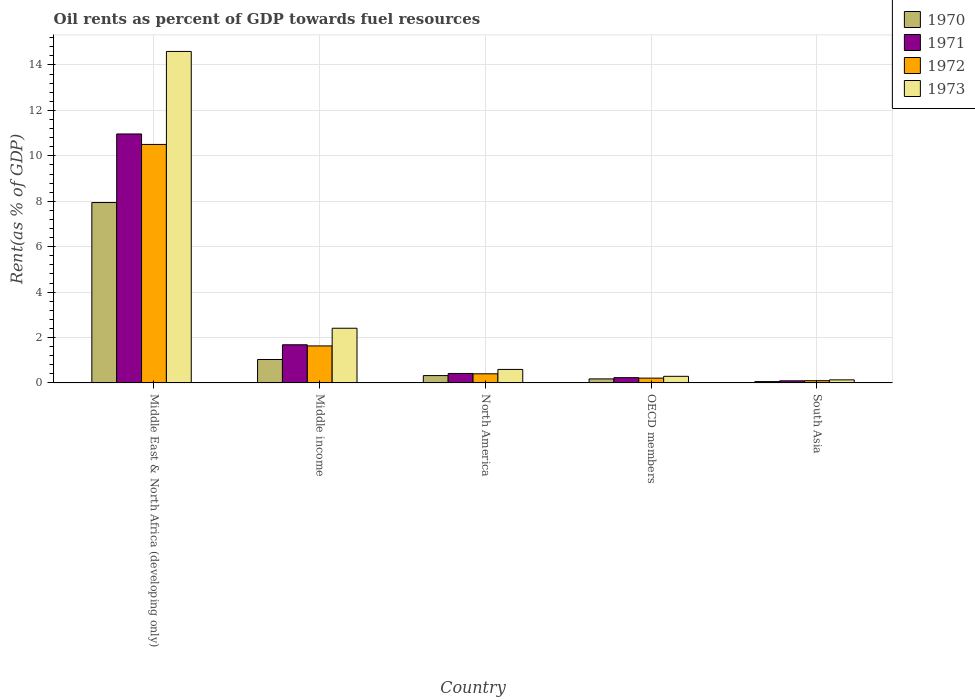Are the number of bars per tick equal to the number of legend labels?
Ensure brevity in your answer.  Yes. How many bars are there on the 5th tick from the right?
Your answer should be very brief. 4. What is the oil rent in 1972 in North America?
Offer a terse response. 0.4. Across all countries, what is the maximum oil rent in 1971?
Ensure brevity in your answer.  10.96. Across all countries, what is the minimum oil rent in 1971?
Provide a short and direct response. 0.09. In which country was the oil rent in 1971 maximum?
Provide a short and direct response. Middle East & North Africa (developing only). In which country was the oil rent in 1971 minimum?
Your response must be concise. South Asia. What is the total oil rent in 1970 in the graph?
Provide a succinct answer. 9.54. What is the difference between the oil rent in 1970 in Middle income and that in South Asia?
Give a very brief answer. 0.97. What is the difference between the oil rent in 1971 in North America and the oil rent in 1972 in OECD members?
Offer a terse response. 0.21. What is the average oil rent in 1972 per country?
Keep it short and to the point. 2.57. What is the difference between the oil rent of/in 1972 and oil rent of/in 1973 in Middle income?
Make the answer very short. -0.78. In how many countries, is the oil rent in 1972 greater than 9.6 %?
Ensure brevity in your answer.  1. What is the ratio of the oil rent in 1970 in Middle income to that in South Asia?
Your answer should be very brief. 17.23. Is the oil rent in 1972 in Middle income less than that in North America?
Offer a very short reply. No. Is the difference between the oil rent in 1972 in Middle income and South Asia greater than the difference between the oil rent in 1973 in Middle income and South Asia?
Give a very brief answer. No. What is the difference between the highest and the second highest oil rent in 1973?
Give a very brief answer. -1.81. What is the difference between the highest and the lowest oil rent in 1970?
Your response must be concise. 7.88. In how many countries, is the oil rent in 1971 greater than the average oil rent in 1971 taken over all countries?
Your answer should be very brief. 1. Is the sum of the oil rent in 1972 in Middle income and OECD members greater than the maximum oil rent in 1971 across all countries?
Make the answer very short. No. What does the 1st bar from the left in South Asia represents?
Ensure brevity in your answer.  1970. What does the 3rd bar from the right in Middle income represents?
Offer a terse response. 1971. How many bars are there?
Your response must be concise. 20. How many countries are there in the graph?
Your answer should be very brief. 5. Does the graph contain any zero values?
Offer a very short reply. No. How many legend labels are there?
Give a very brief answer. 4. What is the title of the graph?
Keep it short and to the point. Oil rents as percent of GDP towards fuel resources. What is the label or title of the Y-axis?
Your answer should be compact. Rent(as % of GDP). What is the Rent(as % of GDP) in 1970 in Middle East & North Africa (developing only)?
Your response must be concise. 7.94. What is the Rent(as % of GDP) in 1971 in Middle East & North Africa (developing only)?
Offer a very short reply. 10.96. What is the Rent(as % of GDP) of 1972 in Middle East & North Africa (developing only)?
Offer a terse response. 10.5. What is the Rent(as % of GDP) in 1973 in Middle East & North Africa (developing only)?
Your response must be concise. 14.6. What is the Rent(as % of GDP) of 1970 in Middle income?
Ensure brevity in your answer.  1.03. What is the Rent(as % of GDP) in 1971 in Middle income?
Provide a succinct answer. 1.68. What is the Rent(as % of GDP) of 1972 in Middle income?
Your answer should be very brief. 1.63. What is the Rent(as % of GDP) in 1973 in Middle income?
Your answer should be compact. 2.41. What is the Rent(as % of GDP) of 1970 in North America?
Keep it short and to the point. 0.32. What is the Rent(as % of GDP) in 1971 in North America?
Your answer should be compact. 0.42. What is the Rent(as % of GDP) in 1972 in North America?
Ensure brevity in your answer.  0.4. What is the Rent(as % of GDP) in 1973 in North America?
Offer a very short reply. 0.6. What is the Rent(as % of GDP) in 1970 in OECD members?
Provide a short and direct response. 0.18. What is the Rent(as % of GDP) of 1971 in OECD members?
Make the answer very short. 0.23. What is the Rent(as % of GDP) in 1972 in OECD members?
Give a very brief answer. 0.21. What is the Rent(as % of GDP) of 1973 in OECD members?
Your response must be concise. 0.29. What is the Rent(as % of GDP) of 1970 in South Asia?
Keep it short and to the point. 0.06. What is the Rent(as % of GDP) in 1971 in South Asia?
Your answer should be very brief. 0.09. What is the Rent(as % of GDP) in 1972 in South Asia?
Make the answer very short. 0.1. What is the Rent(as % of GDP) in 1973 in South Asia?
Ensure brevity in your answer.  0.14. Across all countries, what is the maximum Rent(as % of GDP) in 1970?
Your response must be concise. 7.94. Across all countries, what is the maximum Rent(as % of GDP) of 1971?
Your answer should be compact. 10.96. Across all countries, what is the maximum Rent(as % of GDP) in 1972?
Your response must be concise. 10.5. Across all countries, what is the maximum Rent(as % of GDP) of 1973?
Offer a terse response. 14.6. Across all countries, what is the minimum Rent(as % of GDP) of 1970?
Your answer should be compact. 0.06. Across all countries, what is the minimum Rent(as % of GDP) of 1971?
Make the answer very short. 0.09. Across all countries, what is the minimum Rent(as % of GDP) of 1972?
Your answer should be very brief. 0.1. Across all countries, what is the minimum Rent(as % of GDP) in 1973?
Offer a terse response. 0.14. What is the total Rent(as % of GDP) of 1970 in the graph?
Your answer should be very brief. 9.54. What is the total Rent(as % of GDP) in 1971 in the graph?
Provide a succinct answer. 13.39. What is the total Rent(as % of GDP) of 1972 in the graph?
Your answer should be compact. 12.85. What is the total Rent(as % of GDP) of 1973 in the graph?
Your answer should be compact. 18.03. What is the difference between the Rent(as % of GDP) in 1970 in Middle East & North Africa (developing only) and that in Middle income?
Your answer should be very brief. 6.91. What is the difference between the Rent(as % of GDP) of 1971 in Middle East & North Africa (developing only) and that in Middle income?
Keep it short and to the point. 9.28. What is the difference between the Rent(as % of GDP) in 1972 in Middle East & North Africa (developing only) and that in Middle income?
Make the answer very short. 8.87. What is the difference between the Rent(as % of GDP) of 1973 in Middle East & North Africa (developing only) and that in Middle income?
Your answer should be compact. 12.19. What is the difference between the Rent(as % of GDP) in 1970 in Middle East & North Africa (developing only) and that in North America?
Provide a succinct answer. 7.62. What is the difference between the Rent(as % of GDP) of 1971 in Middle East & North Africa (developing only) and that in North America?
Your answer should be very brief. 10.55. What is the difference between the Rent(as % of GDP) in 1972 in Middle East & North Africa (developing only) and that in North America?
Provide a succinct answer. 10.1. What is the difference between the Rent(as % of GDP) of 1973 in Middle East & North Africa (developing only) and that in North America?
Keep it short and to the point. 14. What is the difference between the Rent(as % of GDP) of 1970 in Middle East & North Africa (developing only) and that in OECD members?
Your answer should be compact. 7.77. What is the difference between the Rent(as % of GDP) of 1971 in Middle East & North Africa (developing only) and that in OECD members?
Provide a succinct answer. 10.73. What is the difference between the Rent(as % of GDP) in 1972 in Middle East & North Africa (developing only) and that in OECD members?
Offer a very short reply. 10.29. What is the difference between the Rent(as % of GDP) of 1973 in Middle East & North Africa (developing only) and that in OECD members?
Provide a succinct answer. 14.3. What is the difference between the Rent(as % of GDP) in 1970 in Middle East & North Africa (developing only) and that in South Asia?
Your answer should be compact. 7.88. What is the difference between the Rent(as % of GDP) in 1971 in Middle East & North Africa (developing only) and that in South Asia?
Give a very brief answer. 10.87. What is the difference between the Rent(as % of GDP) of 1972 in Middle East & North Africa (developing only) and that in South Asia?
Keep it short and to the point. 10.4. What is the difference between the Rent(as % of GDP) of 1973 in Middle East & North Africa (developing only) and that in South Asia?
Your answer should be very brief. 14.46. What is the difference between the Rent(as % of GDP) in 1970 in Middle income and that in North America?
Your answer should be very brief. 0.71. What is the difference between the Rent(as % of GDP) of 1971 in Middle income and that in North America?
Offer a terse response. 1.26. What is the difference between the Rent(as % of GDP) of 1972 in Middle income and that in North America?
Offer a terse response. 1.23. What is the difference between the Rent(as % of GDP) in 1973 in Middle income and that in North America?
Give a very brief answer. 1.81. What is the difference between the Rent(as % of GDP) of 1970 in Middle income and that in OECD members?
Offer a terse response. 0.85. What is the difference between the Rent(as % of GDP) of 1971 in Middle income and that in OECD members?
Provide a succinct answer. 1.45. What is the difference between the Rent(as % of GDP) in 1972 in Middle income and that in OECD members?
Give a very brief answer. 1.42. What is the difference between the Rent(as % of GDP) of 1973 in Middle income and that in OECD members?
Give a very brief answer. 2.12. What is the difference between the Rent(as % of GDP) of 1970 in Middle income and that in South Asia?
Your answer should be compact. 0.97. What is the difference between the Rent(as % of GDP) in 1971 in Middle income and that in South Asia?
Ensure brevity in your answer.  1.59. What is the difference between the Rent(as % of GDP) of 1972 in Middle income and that in South Asia?
Give a very brief answer. 1.53. What is the difference between the Rent(as % of GDP) of 1973 in Middle income and that in South Asia?
Provide a succinct answer. 2.27. What is the difference between the Rent(as % of GDP) in 1970 in North America and that in OECD members?
Keep it short and to the point. 0.15. What is the difference between the Rent(as % of GDP) of 1971 in North America and that in OECD members?
Offer a very short reply. 0.18. What is the difference between the Rent(as % of GDP) in 1972 in North America and that in OECD members?
Your answer should be compact. 0.19. What is the difference between the Rent(as % of GDP) in 1973 in North America and that in OECD members?
Provide a succinct answer. 0.3. What is the difference between the Rent(as % of GDP) in 1970 in North America and that in South Asia?
Keep it short and to the point. 0.26. What is the difference between the Rent(as % of GDP) in 1971 in North America and that in South Asia?
Ensure brevity in your answer.  0.32. What is the difference between the Rent(as % of GDP) of 1972 in North America and that in South Asia?
Provide a short and direct response. 0.3. What is the difference between the Rent(as % of GDP) in 1973 in North America and that in South Asia?
Your response must be concise. 0.46. What is the difference between the Rent(as % of GDP) in 1970 in OECD members and that in South Asia?
Provide a short and direct response. 0.12. What is the difference between the Rent(as % of GDP) of 1971 in OECD members and that in South Asia?
Provide a short and direct response. 0.14. What is the difference between the Rent(as % of GDP) of 1972 in OECD members and that in South Asia?
Offer a terse response. 0.11. What is the difference between the Rent(as % of GDP) of 1973 in OECD members and that in South Asia?
Provide a succinct answer. 0.16. What is the difference between the Rent(as % of GDP) in 1970 in Middle East & North Africa (developing only) and the Rent(as % of GDP) in 1971 in Middle income?
Offer a very short reply. 6.26. What is the difference between the Rent(as % of GDP) of 1970 in Middle East & North Africa (developing only) and the Rent(as % of GDP) of 1972 in Middle income?
Your answer should be compact. 6.31. What is the difference between the Rent(as % of GDP) in 1970 in Middle East & North Africa (developing only) and the Rent(as % of GDP) in 1973 in Middle income?
Offer a terse response. 5.53. What is the difference between the Rent(as % of GDP) in 1971 in Middle East & North Africa (developing only) and the Rent(as % of GDP) in 1972 in Middle income?
Your answer should be compact. 9.33. What is the difference between the Rent(as % of GDP) in 1971 in Middle East & North Africa (developing only) and the Rent(as % of GDP) in 1973 in Middle income?
Offer a very short reply. 8.55. What is the difference between the Rent(as % of GDP) of 1972 in Middle East & North Africa (developing only) and the Rent(as % of GDP) of 1973 in Middle income?
Ensure brevity in your answer.  8.09. What is the difference between the Rent(as % of GDP) in 1970 in Middle East & North Africa (developing only) and the Rent(as % of GDP) in 1971 in North America?
Offer a very short reply. 7.53. What is the difference between the Rent(as % of GDP) in 1970 in Middle East & North Africa (developing only) and the Rent(as % of GDP) in 1972 in North America?
Offer a terse response. 7.54. What is the difference between the Rent(as % of GDP) of 1970 in Middle East & North Africa (developing only) and the Rent(as % of GDP) of 1973 in North America?
Offer a very short reply. 7.35. What is the difference between the Rent(as % of GDP) of 1971 in Middle East & North Africa (developing only) and the Rent(as % of GDP) of 1972 in North America?
Offer a terse response. 10.56. What is the difference between the Rent(as % of GDP) in 1971 in Middle East & North Africa (developing only) and the Rent(as % of GDP) in 1973 in North America?
Offer a very short reply. 10.37. What is the difference between the Rent(as % of GDP) in 1972 in Middle East & North Africa (developing only) and the Rent(as % of GDP) in 1973 in North America?
Provide a short and direct response. 9.91. What is the difference between the Rent(as % of GDP) of 1970 in Middle East & North Africa (developing only) and the Rent(as % of GDP) of 1971 in OECD members?
Give a very brief answer. 7.71. What is the difference between the Rent(as % of GDP) of 1970 in Middle East & North Africa (developing only) and the Rent(as % of GDP) of 1972 in OECD members?
Make the answer very short. 7.73. What is the difference between the Rent(as % of GDP) of 1970 in Middle East & North Africa (developing only) and the Rent(as % of GDP) of 1973 in OECD members?
Make the answer very short. 7.65. What is the difference between the Rent(as % of GDP) of 1971 in Middle East & North Africa (developing only) and the Rent(as % of GDP) of 1972 in OECD members?
Make the answer very short. 10.75. What is the difference between the Rent(as % of GDP) of 1971 in Middle East & North Africa (developing only) and the Rent(as % of GDP) of 1973 in OECD members?
Your answer should be compact. 10.67. What is the difference between the Rent(as % of GDP) in 1972 in Middle East & North Africa (developing only) and the Rent(as % of GDP) in 1973 in OECD members?
Provide a succinct answer. 10.21. What is the difference between the Rent(as % of GDP) of 1970 in Middle East & North Africa (developing only) and the Rent(as % of GDP) of 1971 in South Asia?
Ensure brevity in your answer.  7.85. What is the difference between the Rent(as % of GDP) of 1970 in Middle East & North Africa (developing only) and the Rent(as % of GDP) of 1972 in South Asia?
Your answer should be very brief. 7.84. What is the difference between the Rent(as % of GDP) in 1970 in Middle East & North Africa (developing only) and the Rent(as % of GDP) in 1973 in South Asia?
Offer a very short reply. 7.81. What is the difference between the Rent(as % of GDP) in 1971 in Middle East & North Africa (developing only) and the Rent(as % of GDP) in 1972 in South Asia?
Ensure brevity in your answer.  10.86. What is the difference between the Rent(as % of GDP) of 1971 in Middle East & North Africa (developing only) and the Rent(as % of GDP) of 1973 in South Asia?
Provide a short and direct response. 10.83. What is the difference between the Rent(as % of GDP) in 1972 in Middle East & North Africa (developing only) and the Rent(as % of GDP) in 1973 in South Asia?
Offer a very short reply. 10.37. What is the difference between the Rent(as % of GDP) of 1970 in Middle income and the Rent(as % of GDP) of 1971 in North America?
Offer a very short reply. 0.61. What is the difference between the Rent(as % of GDP) of 1970 in Middle income and the Rent(as % of GDP) of 1972 in North America?
Provide a short and direct response. 0.63. What is the difference between the Rent(as % of GDP) in 1970 in Middle income and the Rent(as % of GDP) in 1973 in North America?
Provide a succinct answer. 0.44. What is the difference between the Rent(as % of GDP) of 1971 in Middle income and the Rent(as % of GDP) of 1972 in North America?
Your answer should be very brief. 1.28. What is the difference between the Rent(as % of GDP) in 1971 in Middle income and the Rent(as % of GDP) in 1973 in North America?
Offer a terse response. 1.09. What is the difference between the Rent(as % of GDP) in 1972 in Middle income and the Rent(as % of GDP) in 1973 in North America?
Your answer should be very brief. 1.04. What is the difference between the Rent(as % of GDP) of 1970 in Middle income and the Rent(as % of GDP) of 1971 in OECD members?
Your answer should be compact. 0.8. What is the difference between the Rent(as % of GDP) of 1970 in Middle income and the Rent(as % of GDP) of 1972 in OECD members?
Your answer should be compact. 0.82. What is the difference between the Rent(as % of GDP) in 1970 in Middle income and the Rent(as % of GDP) in 1973 in OECD members?
Ensure brevity in your answer.  0.74. What is the difference between the Rent(as % of GDP) in 1971 in Middle income and the Rent(as % of GDP) in 1972 in OECD members?
Make the answer very short. 1.47. What is the difference between the Rent(as % of GDP) in 1971 in Middle income and the Rent(as % of GDP) in 1973 in OECD members?
Give a very brief answer. 1.39. What is the difference between the Rent(as % of GDP) in 1972 in Middle income and the Rent(as % of GDP) in 1973 in OECD members?
Offer a very short reply. 1.34. What is the difference between the Rent(as % of GDP) of 1970 in Middle income and the Rent(as % of GDP) of 1971 in South Asia?
Provide a short and direct response. 0.94. What is the difference between the Rent(as % of GDP) of 1970 in Middle income and the Rent(as % of GDP) of 1972 in South Asia?
Provide a short and direct response. 0.93. What is the difference between the Rent(as % of GDP) of 1970 in Middle income and the Rent(as % of GDP) of 1973 in South Asia?
Make the answer very short. 0.9. What is the difference between the Rent(as % of GDP) of 1971 in Middle income and the Rent(as % of GDP) of 1972 in South Asia?
Offer a very short reply. 1.58. What is the difference between the Rent(as % of GDP) of 1971 in Middle income and the Rent(as % of GDP) of 1973 in South Asia?
Your answer should be compact. 1.55. What is the difference between the Rent(as % of GDP) in 1972 in Middle income and the Rent(as % of GDP) in 1973 in South Asia?
Provide a succinct answer. 1.5. What is the difference between the Rent(as % of GDP) in 1970 in North America and the Rent(as % of GDP) in 1971 in OECD members?
Offer a terse response. 0.09. What is the difference between the Rent(as % of GDP) of 1970 in North America and the Rent(as % of GDP) of 1972 in OECD members?
Offer a very short reply. 0.11. What is the difference between the Rent(as % of GDP) of 1970 in North America and the Rent(as % of GDP) of 1973 in OECD members?
Your response must be concise. 0.03. What is the difference between the Rent(as % of GDP) of 1971 in North America and the Rent(as % of GDP) of 1972 in OECD members?
Provide a short and direct response. 0.21. What is the difference between the Rent(as % of GDP) of 1971 in North America and the Rent(as % of GDP) of 1973 in OECD members?
Offer a very short reply. 0.13. What is the difference between the Rent(as % of GDP) of 1972 in North America and the Rent(as % of GDP) of 1973 in OECD members?
Ensure brevity in your answer.  0.11. What is the difference between the Rent(as % of GDP) of 1970 in North America and the Rent(as % of GDP) of 1971 in South Asia?
Offer a terse response. 0.23. What is the difference between the Rent(as % of GDP) in 1970 in North America and the Rent(as % of GDP) in 1972 in South Asia?
Offer a very short reply. 0.23. What is the difference between the Rent(as % of GDP) in 1970 in North America and the Rent(as % of GDP) in 1973 in South Asia?
Offer a very short reply. 0.19. What is the difference between the Rent(as % of GDP) in 1971 in North America and the Rent(as % of GDP) in 1972 in South Asia?
Give a very brief answer. 0.32. What is the difference between the Rent(as % of GDP) in 1971 in North America and the Rent(as % of GDP) in 1973 in South Asia?
Make the answer very short. 0.28. What is the difference between the Rent(as % of GDP) of 1972 in North America and the Rent(as % of GDP) of 1973 in South Asia?
Make the answer very short. 0.27. What is the difference between the Rent(as % of GDP) in 1970 in OECD members and the Rent(as % of GDP) in 1971 in South Asia?
Keep it short and to the point. 0.08. What is the difference between the Rent(as % of GDP) of 1970 in OECD members and the Rent(as % of GDP) of 1972 in South Asia?
Offer a terse response. 0.08. What is the difference between the Rent(as % of GDP) in 1970 in OECD members and the Rent(as % of GDP) in 1973 in South Asia?
Your response must be concise. 0.04. What is the difference between the Rent(as % of GDP) of 1971 in OECD members and the Rent(as % of GDP) of 1972 in South Asia?
Provide a succinct answer. 0.13. What is the difference between the Rent(as % of GDP) of 1971 in OECD members and the Rent(as % of GDP) of 1973 in South Asia?
Your response must be concise. 0.1. What is the difference between the Rent(as % of GDP) in 1972 in OECD members and the Rent(as % of GDP) in 1973 in South Asia?
Give a very brief answer. 0.08. What is the average Rent(as % of GDP) of 1970 per country?
Provide a short and direct response. 1.91. What is the average Rent(as % of GDP) of 1971 per country?
Provide a succinct answer. 2.68. What is the average Rent(as % of GDP) of 1972 per country?
Make the answer very short. 2.57. What is the average Rent(as % of GDP) in 1973 per country?
Keep it short and to the point. 3.61. What is the difference between the Rent(as % of GDP) of 1970 and Rent(as % of GDP) of 1971 in Middle East & North Africa (developing only)?
Your response must be concise. -3.02. What is the difference between the Rent(as % of GDP) of 1970 and Rent(as % of GDP) of 1972 in Middle East & North Africa (developing only)?
Your answer should be very brief. -2.56. What is the difference between the Rent(as % of GDP) of 1970 and Rent(as % of GDP) of 1973 in Middle East & North Africa (developing only)?
Your response must be concise. -6.65. What is the difference between the Rent(as % of GDP) of 1971 and Rent(as % of GDP) of 1972 in Middle East & North Africa (developing only)?
Give a very brief answer. 0.46. What is the difference between the Rent(as % of GDP) of 1971 and Rent(as % of GDP) of 1973 in Middle East & North Africa (developing only)?
Provide a short and direct response. -3.63. What is the difference between the Rent(as % of GDP) of 1972 and Rent(as % of GDP) of 1973 in Middle East & North Africa (developing only)?
Provide a succinct answer. -4.09. What is the difference between the Rent(as % of GDP) of 1970 and Rent(as % of GDP) of 1971 in Middle income?
Your answer should be very brief. -0.65. What is the difference between the Rent(as % of GDP) of 1970 and Rent(as % of GDP) of 1972 in Middle income?
Provide a short and direct response. -0.6. What is the difference between the Rent(as % of GDP) of 1970 and Rent(as % of GDP) of 1973 in Middle income?
Your response must be concise. -1.38. What is the difference between the Rent(as % of GDP) in 1971 and Rent(as % of GDP) in 1972 in Middle income?
Offer a very short reply. 0.05. What is the difference between the Rent(as % of GDP) in 1971 and Rent(as % of GDP) in 1973 in Middle income?
Your response must be concise. -0.73. What is the difference between the Rent(as % of GDP) in 1972 and Rent(as % of GDP) in 1973 in Middle income?
Provide a succinct answer. -0.78. What is the difference between the Rent(as % of GDP) in 1970 and Rent(as % of GDP) in 1971 in North America?
Keep it short and to the point. -0.09. What is the difference between the Rent(as % of GDP) in 1970 and Rent(as % of GDP) in 1972 in North America?
Provide a succinct answer. -0.08. What is the difference between the Rent(as % of GDP) of 1970 and Rent(as % of GDP) of 1973 in North America?
Offer a very short reply. -0.27. What is the difference between the Rent(as % of GDP) of 1971 and Rent(as % of GDP) of 1972 in North America?
Offer a very short reply. 0.02. What is the difference between the Rent(as % of GDP) of 1971 and Rent(as % of GDP) of 1973 in North America?
Your answer should be very brief. -0.18. What is the difference between the Rent(as % of GDP) in 1972 and Rent(as % of GDP) in 1973 in North America?
Your response must be concise. -0.19. What is the difference between the Rent(as % of GDP) of 1970 and Rent(as % of GDP) of 1971 in OECD members?
Keep it short and to the point. -0.05. What is the difference between the Rent(as % of GDP) in 1970 and Rent(as % of GDP) in 1972 in OECD members?
Ensure brevity in your answer.  -0.03. What is the difference between the Rent(as % of GDP) of 1970 and Rent(as % of GDP) of 1973 in OECD members?
Your answer should be compact. -0.11. What is the difference between the Rent(as % of GDP) of 1971 and Rent(as % of GDP) of 1972 in OECD members?
Offer a terse response. 0.02. What is the difference between the Rent(as % of GDP) in 1971 and Rent(as % of GDP) in 1973 in OECD members?
Ensure brevity in your answer.  -0.06. What is the difference between the Rent(as % of GDP) of 1972 and Rent(as % of GDP) of 1973 in OECD members?
Offer a very short reply. -0.08. What is the difference between the Rent(as % of GDP) in 1970 and Rent(as % of GDP) in 1971 in South Asia?
Offer a terse response. -0.03. What is the difference between the Rent(as % of GDP) of 1970 and Rent(as % of GDP) of 1972 in South Asia?
Provide a short and direct response. -0.04. What is the difference between the Rent(as % of GDP) of 1970 and Rent(as % of GDP) of 1973 in South Asia?
Make the answer very short. -0.08. What is the difference between the Rent(as % of GDP) of 1971 and Rent(as % of GDP) of 1972 in South Asia?
Give a very brief answer. -0.01. What is the difference between the Rent(as % of GDP) of 1971 and Rent(as % of GDP) of 1973 in South Asia?
Keep it short and to the point. -0.04. What is the difference between the Rent(as % of GDP) of 1972 and Rent(as % of GDP) of 1973 in South Asia?
Provide a short and direct response. -0.04. What is the ratio of the Rent(as % of GDP) in 1970 in Middle East & North Africa (developing only) to that in Middle income?
Your answer should be compact. 7.69. What is the ratio of the Rent(as % of GDP) in 1971 in Middle East & North Africa (developing only) to that in Middle income?
Make the answer very short. 6.52. What is the ratio of the Rent(as % of GDP) in 1972 in Middle East & North Africa (developing only) to that in Middle income?
Offer a terse response. 6.44. What is the ratio of the Rent(as % of GDP) of 1973 in Middle East & North Africa (developing only) to that in Middle income?
Your response must be concise. 6.06. What is the ratio of the Rent(as % of GDP) in 1970 in Middle East & North Africa (developing only) to that in North America?
Keep it short and to the point. 24.54. What is the ratio of the Rent(as % of GDP) of 1971 in Middle East & North Africa (developing only) to that in North America?
Give a very brief answer. 26.26. What is the ratio of the Rent(as % of GDP) in 1972 in Middle East & North Africa (developing only) to that in North America?
Offer a very short reply. 26.11. What is the ratio of the Rent(as % of GDP) of 1973 in Middle East & North Africa (developing only) to that in North America?
Your answer should be very brief. 24.53. What is the ratio of the Rent(as % of GDP) in 1970 in Middle East & North Africa (developing only) to that in OECD members?
Offer a very short reply. 44.68. What is the ratio of the Rent(as % of GDP) in 1971 in Middle East & North Africa (developing only) to that in OECD members?
Provide a succinct answer. 47.15. What is the ratio of the Rent(as % of GDP) of 1972 in Middle East & North Africa (developing only) to that in OECD members?
Your answer should be very brief. 49.49. What is the ratio of the Rent(as % of GDP) in 1973 in Middle East & North Africa (developing only) to that in OECD members?
Keep it short and to the point. 50.04. What is the ratio of the Rent(as % of GDP) in 1970 in Middle East & North Africa (developing only) to that in South Asia?
Your answer should be compact. 132.59. What is the ratio of the Rent(as % of GDP) in 1971 in Middle East & North Africa (developing only) to that in South Asia?
Provide a succinct answer. 117.69. What is the ratio of the Rent(as % of GDP) of 1972 in Middle East & North Africa (developing only) to that in South Asia?
Your response must be concise. 106.59. What is the ratio of the Rent(as % of GDP) of 1973 in Middle East & North Africa (developing only) to that in South Asia?
Provide a short and direct response. 108.09. What is the ratio of the Rent(as % of GDP) in 1970 in Middle income to that in North America?
Your answer should be compact. 3.19. What is the ratio of the Rent(as % of GDP) of 1971 in Middle income to that in North America?
Offer a very short reply. 4.03. What is the ratio of the Rent(as % of GDP) of 1972 in Middle income to that in North America?
Keep it short and to the point. 4.05. What is the ratio of the Rent(as % of GDP) of 1973 in Middle income to that in North America?
Offer a terse response. 4.05. What is the ratio of the Rent(as % of GDP) of 1970 in Middle income to that in OECD members?
Ensure brevity in your answer.  5.81. What is the ratio of the Rent(as % of GDP) in 1971 in Middle income to that in OECD members?
Your answer should be very brief. 7.23. What is the ratio of the Rent(as % of GDP) in 1972 in Middle income to that in OECD members?
Keep it short and to the point. 7.68. What is the ratio of the Rent(as % of GDP) of 1973 in Middle income to that in OECD members?
Your answer should be compact. 8.26. What is the ratio of the Rent(as % of GDP) in 1970 in Middle income to that in South Asia?
Make the answer very short. 17.23. What is the ratio of the Rent(as % of GDP) of 1971 in Middle income to that in South Asia?
Ensure brevity in your answer.  18.04. What is the ratio of the Rent(as % of GDP) in 1972 in Middle income to that in South Asia?
Your answer should be compact. 16.55. What is the ratio of the Rent(as % of GDP) of 1973 in Middle income to that in South Asia?
Provide a short and direct response. 17.84. What is the ratio of the Rent(as % of GDP) of 1970 in North America to that in OECD members?
Make the answer very short. 1.82. What is the ratio of the Rent(as % of GDP) in 1971 in North America to that in OECD members?
Your answer should be very brief. 1.8. What is the ratio of the Rent(as % of GDP) in 1972 in North America to that in OECD members?
Ensure brevity in your answer.  1.9. What is the ratio of the Rent(as % of GDP) of 1973 in North America to that in OECD members?
Offer a very short reply. 2.04. What is the ratio of the Rent(as % of GDP) of 1970 in North America to that in South Asia?
Offer a terse response. 5.4. What is the ratio of the Rent(as % of GDP) of 1971 in North America to that in South Asia?
Provide a succinct answer. 4.48. What is the ratio of the Rent(as % of GDP) in 1972 in North America to that in South Asia?
Provide a short and direct response. 4.08. What is the ratio of the Rent(as % of GDP) in 1973 in North America to that in South Asia?
Keep it short and to the point. 4.41. What is the ratio of the Rent(as % of GDP) in 1970 in OECD members to that in South Asia?
Ensure brevity in your answer.  2.97. What is the ratio of the Rent(as % of GDP) of 1971 in OECD members to that in South Asia?
Offer a terse response. 2.5. What is the ratio of the Rent(as % of GDP) in 1972 in OECD members to that in South Asia?
Provide a short and direct response. 2.15. What is the ratio of the Rent(as % of GDP) in 1973 in OECD members to that in South Asia?
Offer a very short reply. 2.16. What is the difference between the highest and the second highest Rent(as % of GDP) in 1970?
Keep it short and to the point. 6.91. What is the difference between the highest and the second highest Rent(as % of GDP) in 1971?
Offer a terse response. 9.28. What is the difference between the highest and the second highest Rent(as % of GDP) in 1972?
Your response must be concise. 8.87. What is the difference between the highest and the second highest Rent(as % of GDP) of 1973?
Give a very brief answer. 12.19. What is the difference between the highest and the lowest Rent(as % of GDP) in 1970?
Ensure brevity in your answer.  7.88. What is the difference between the highest and the lowest Rent(as % of GDP) of 1971?
Provide a short and direct response. 10.87. What is the difference between the highest and the lowest Rent(as % of GDP) of 1972?
Your response must be concise. 10.4. What is the difference between the highest and the lowest Rent(as % of GDP) of 1973?
Offer a terse response. 14.46. 